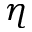<formula> <loc_0><loc_0><loc_500><loc_500>\eta</formula> 